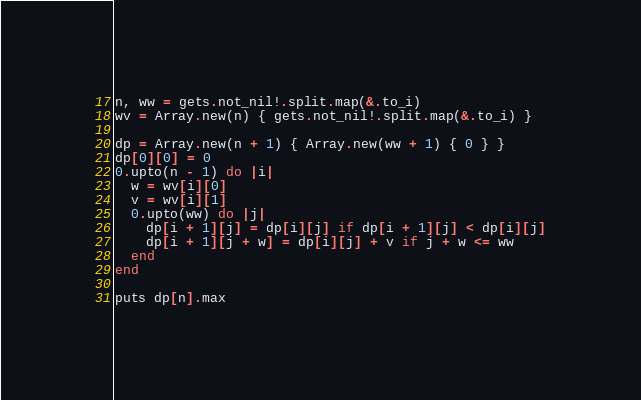Convert code to text. <code><loc_0><loc_0><loc_500><loc_500><_Crystal_>n, ww = gets.not_nil!.split.map(&.to_i)
wv = Array.new(n) { gets.not_nil!.split.map(&.to_i) }

dp = Array.new(n + 1) { Array.new(ww + 1) { 0 } }
dp[0][0] = 0
0.upto(n - 1) do |i|
  w = wv[i][0]
  v = wv[i][1]
  0.upto(ww) do |j|
    dp[i + 1][j] = dp[i][j] if dp[i + 1][j] < dp[i][j]
    dp[i + 1][j + w] = dp[i][j] + v if j + w <= ww
  end
end

puts dp[n].max
</code> 